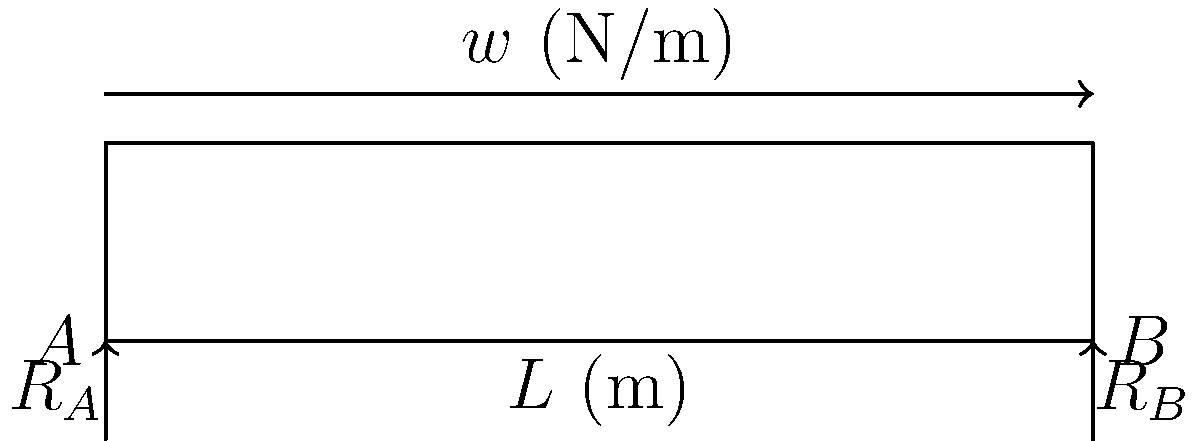A hospital bed frame is modeled as a simply supported beam with a uniformly distributed load $w$ (N/m) along its length $L$ (m). What is the maximum bending moment $M_{max}$ in the bed frame? To find the maximum bending moment in the hospital bed frame, we can follow these steps:

1) For a simply supported beam with a uniformly distributed load, the maximum bending moment occurs at the center of the beam.

2) The formula for the maximum bending moment in this case is:

   $$M_{max} = \frac{wL^2}{8}$$

   Where:
   $w$ is the uniformly distributed load (N/m)
   $L$ is the length of the beam (m)

3) This formula is derived from the general bending moment equation for a simply supported beam with a uniformly distributed load:

   $$M(x) = \frac{wx}{2}(L-x)$$

   Where $x$ is the distance from one end of the beam.

4) The maximum value of this function occurs when $x = L/2$ (at the center of the beam).

5) Substituting $x = L/2$ into the general equation:

   $$M_{max} = M(L/2) = \frac{w(L/2)}{2}(L-L/2) = \frac{wL}{4} \cdot \frac{L}{2} = \frac{wL^2}{8}$$

This formula allows us to calculate the maximum bending moment in the hospital bed frame, which is crucial for ensuring the bed can safely support patients without structural failure.
Answer: $$M_{max} = \frac{wL^2}{8}$$ 